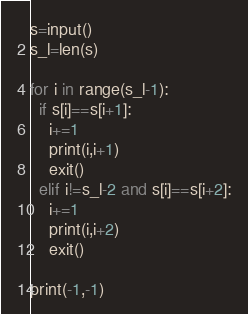Convert code to text. <code><loc_0><loc_0><loc_500><loc_500><_Python_>s=input()
s_l=len(s)

for i in range(s_l-1):
  if s[i]==s[i+1]:
    i+=1
    print(i,i+1)
    exit()
  elif i!=s_l-2 and s[i]==s[i+2]:
    i+=1
    print(i,i+2)
    exit()

print(-1,-1)</code> 